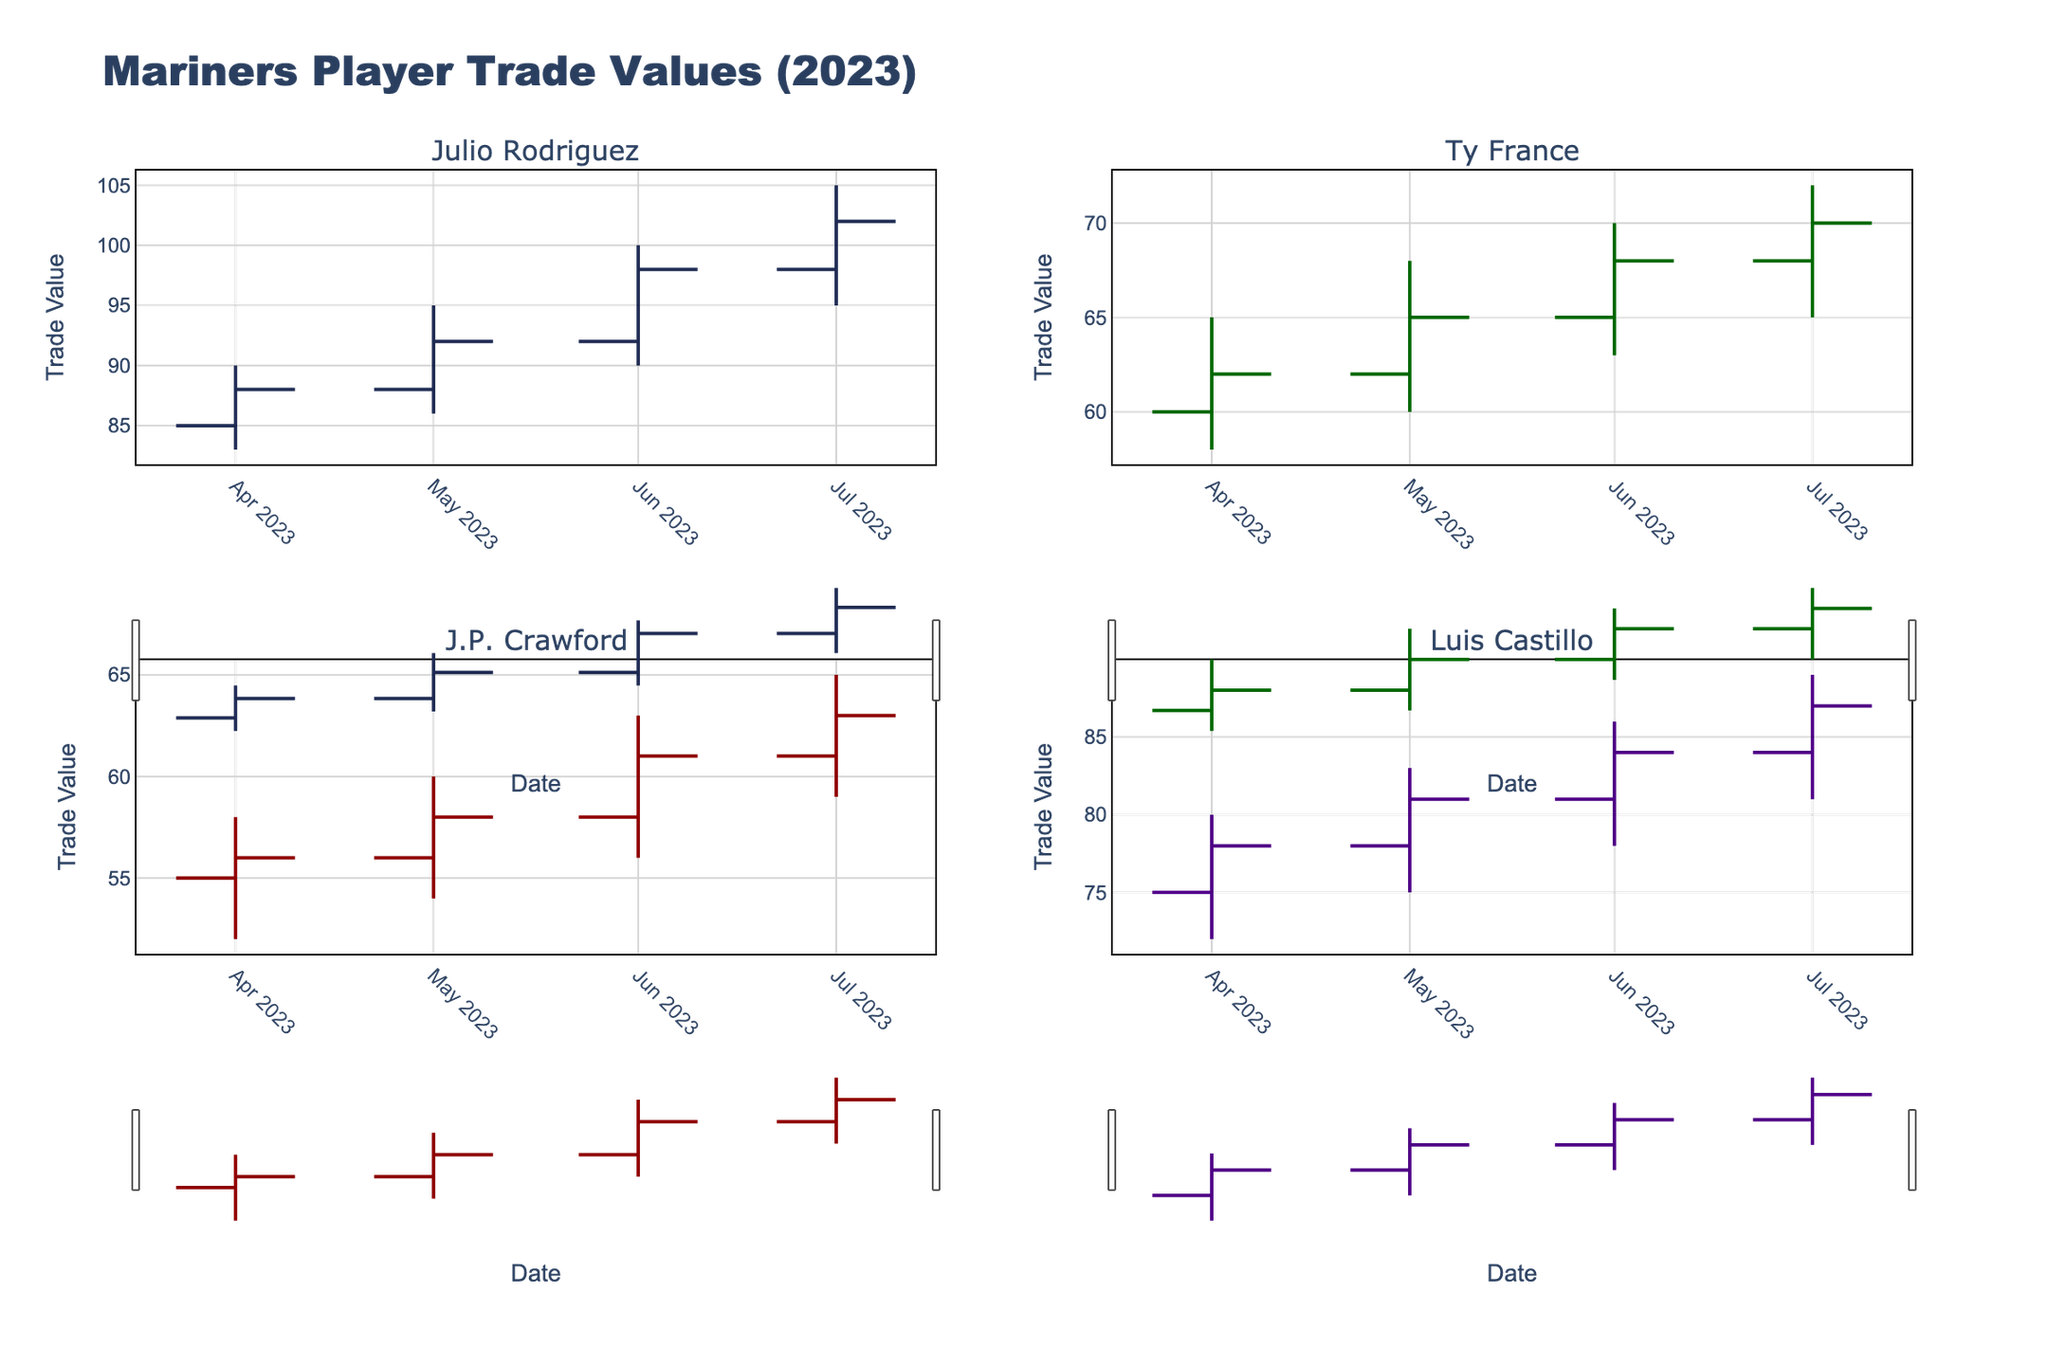What is the title of the figure? The title of the figure is always prominently displayed at the top of the chart. Here, the title is "Mariners Player Trade Values (2023)."
Answer: Mariners Player Trade Values (2023) Which player shows the highest closing trade value in July 2023? To find the highest closing trade value in July 2023, look at the “Close” column for each player. Julio Rodriguez has the highest closing value of 102.
Answer: Julio Rodriguez Between May and June, how did Ty France's closing trade value change? Check the "Close" values for Ty France in May and June. In May, it was 65, and in June, it was 68. The trade value increased by 3.
Answer: Increased by 3 What was the lowest trade value for J.P. Crawford in the dataset? Look at the “Low” column for all months for J.P. Crawford. The lowest value is 52 in April.
Answer: 52 Which player had the most significant increase in closing trade value from April to July 2023? Calculate the difference in the closing values from April to July for each player: Julio Rodriguez (88 to 102 = +14), Ty France (62 to 70 = +8), J.P. Crawford (56 to 63 = +7), Luis Castillo (78 to 87 = +9). Julio Rodriguez had the most significant increase.
Answer: Julio Rodriguez How many players are depicted in the figure? Each subplot represents a player, and there are four subplot titles: Julio Rodriguez, Ty France, J.P. Crawford, and Luis Castillo.
Answer: Four Compare the highest trade value reached by Luis Castillo and Ty France. Who had a higher peak, and what were they? Luis Castillo's highest value (High column) is 89 in July. Ty France's highest value is 72 in July. Luis Castillo had a higher peak at 89.
Answer: Luis Castillo, 89 What is the average closing value for J.P. Crawford from April to July 2023? Sum all closing values for J.P. Crawford (56 + 58 + 61 + 63) = 238. Then divide by 4 (number of data points): 238 / 4 = 59.5.
Answer: 59.5 Which two players have the closest opening trade values in July 2023 and what are they? Compare the "Open" values for July 2023: Julio Rodriguez (98), Ty France (68), J.P. Crawford (61), Luis Castillo (84). J.P. Crawford and Luis Castillo have the closest opening values at 61 and 84, a difference of 23.
Answer: J.P. Crawford and Luis Castillo, 61 and 84 